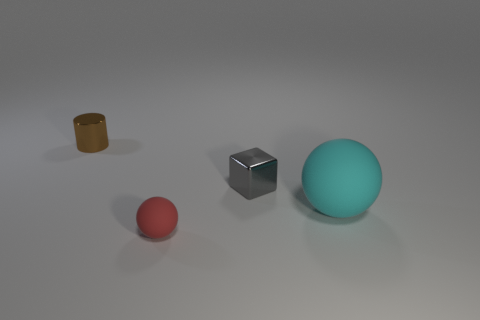Add 4 large purple cylinders. How many objects exist? 8 Subtract all cylinders. How many objects are left? 3 Subtract 0 green blocks. How many objects are left? 4 Subtract all tiny red balls. Subtract all tiny metallic cylinders. How many objects are left? 2 Add 4 small brown cylinders. How many small brown cylinders are left? 5 Add 2 cyan matte things. How many cyan matte things exist? 3 